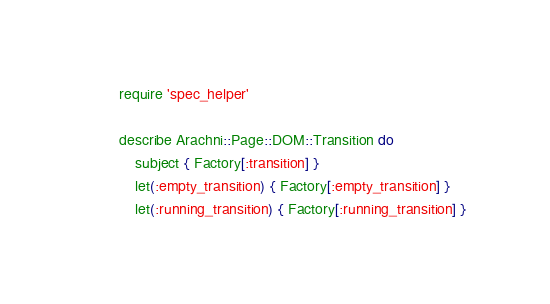<code> <loc_0><loc_0><loc_500><loc_500><_Ruby_>require 'spec_helper'

describe Arachni::Page::DOM::Transition do
    subject { Factory[:transition] }
    let(:empty_transition) { Factory[:empty_transition] }
    let(:running_transition) { Factory[:running_transition] }</code> 